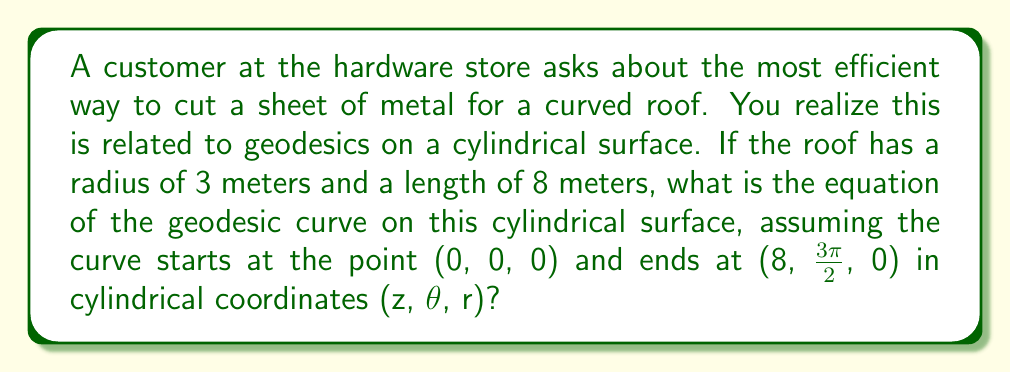Can you solve this math problem? Let's approach this step-by-step:

1) In cylindrical coordinates, a general geodesic on a cylinder of radius $a$ is given by the equation:

   $$z = c_1 \theta + c_2$$

   where $c_1$ and $c_2$ are constants determined by the boundary conditions.

2) We know that:
   - The cylinder radius $a = 3$ meters
   - The start point is (0, 0, 0)
   - The end point is (8, $\frac{3\pi}{2}$, 0)

3) Using the start point (0, 0, 0), we can determine $c_2$:
   
   $$0 = c_1 \cdot 0 + c_2$$
   $$c_2 = 0$$

4) Now, using the end point (8, $\frac{3\pi}{2}$, 0):

   $$8 = c_1 \cdot \frac{3\pi}{2} + 0$$

5) Solving for $c_1$:

   $$c_1 = \frac{8}{\frac{3\pi}{2}} = \frac{16}{3\pi}$$

6) Therefore, the equation of the geodesic is:

   $$z = \frac{16}{3\pi} \theta$$

This equation describes the most efficient cutting path on the cylindrical metal sheet for the curved roof.
Answer: $$z = \frac{16}{3\pi} \theta$$ 